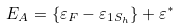Convert formula to latex. <formula><loc_0><loc_0><loc_500><loc_500>E _ { A } = \{ \varepsilon _ { F } - \varepsilon _ { 1 S _ { h } } \} + \varepsilon ^ { * }</formula> 